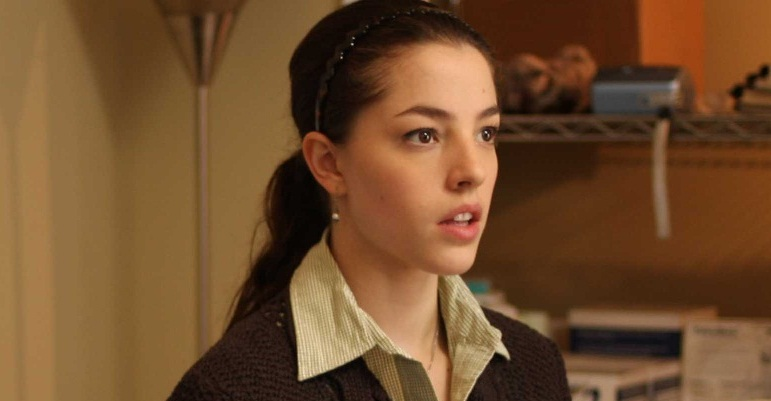Explain the visual content of the image in great detail. In the image, a young woman is portrayed in a moment of quiet introspection. She stands against the backdrop of a softly lit beige wall, with a metallic shelf visible behind her, housing various objects that seem to belong in a home or small office setting. The woman is dressed in a green collared shirt layered with a dark brown knitted cardigan, exuding an air of casual yet thoughtful elegance. A black headband holds her dark hair neatly back into a low ponytail, complementing her poised appearance. Her gaze is directed off to the side with a slightly parted mouth, her expression serious and contemplative, suggesting deep thought or intense focus. The overall atmosphere is one of quiet intensity and introspection. 